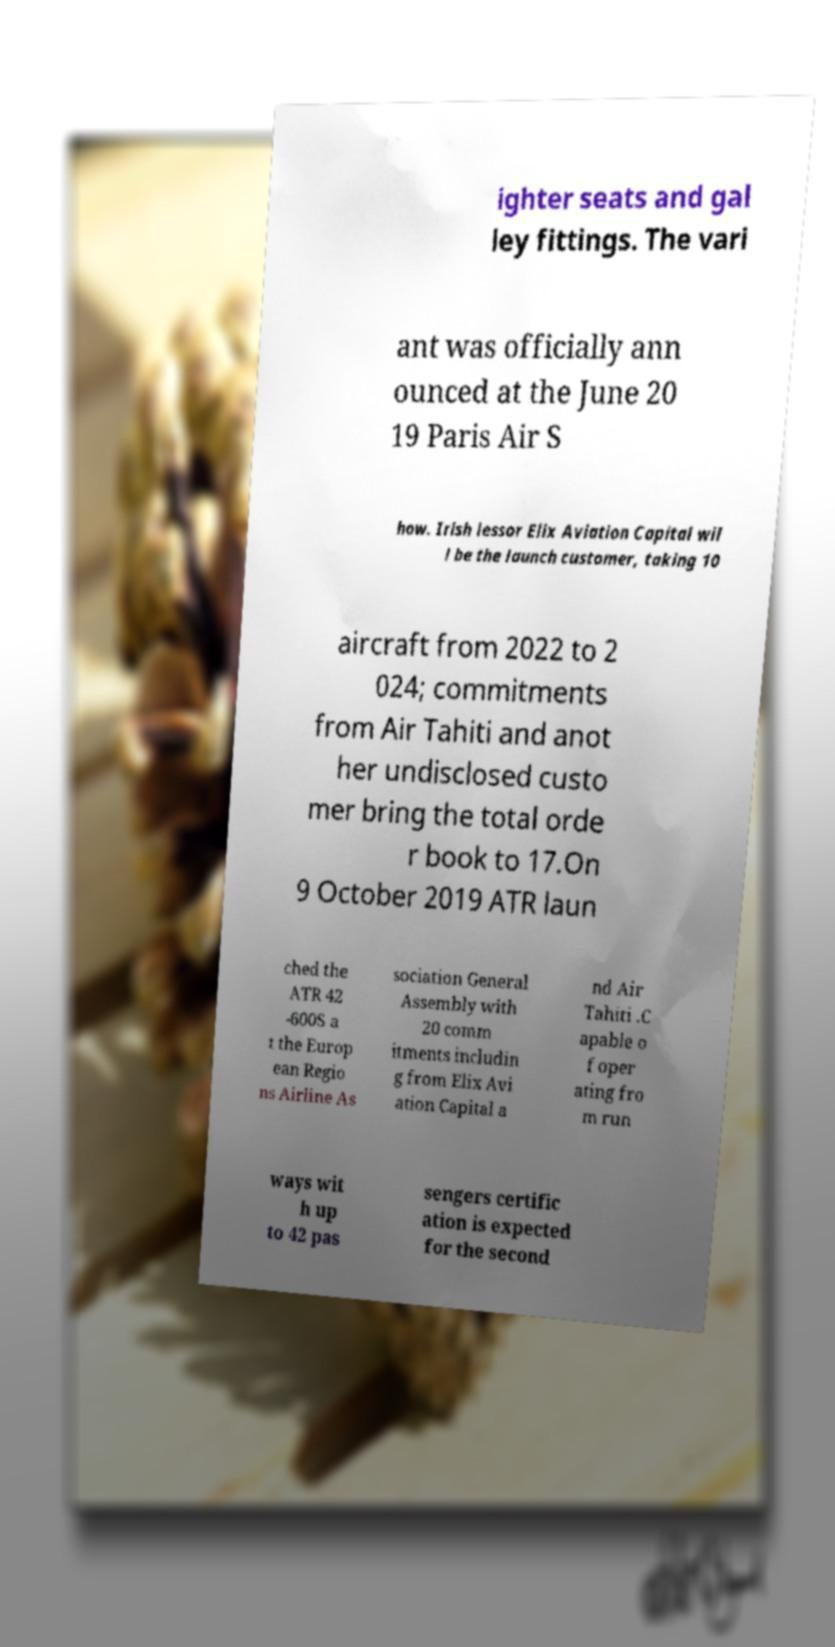Please read and relay the text visible in this image. What does it say? ighter seats and gal ley fittings. The vari ant was officially ann ounced at the June 20 19 Paris Air S how. Irish lessor Elix Aviation Capital wil l be the launch customer, taking 10 aircraft from 2022 to 2 024; commitments from Air Tahiti and anot her undisclosed custo mer bring the total orde r book to 17.On 9 October 2019 ATR laun ched the ATR 42 -600S a t the Europ ean Regio ns Airline As sociation General Assembly with 20 comm itments includin g from Elix Avi ation Capital a nd Air Tahiti .C apable o f oper ating fro m run ways wit h up to 42 pas sengers certific ation is expected for the second 